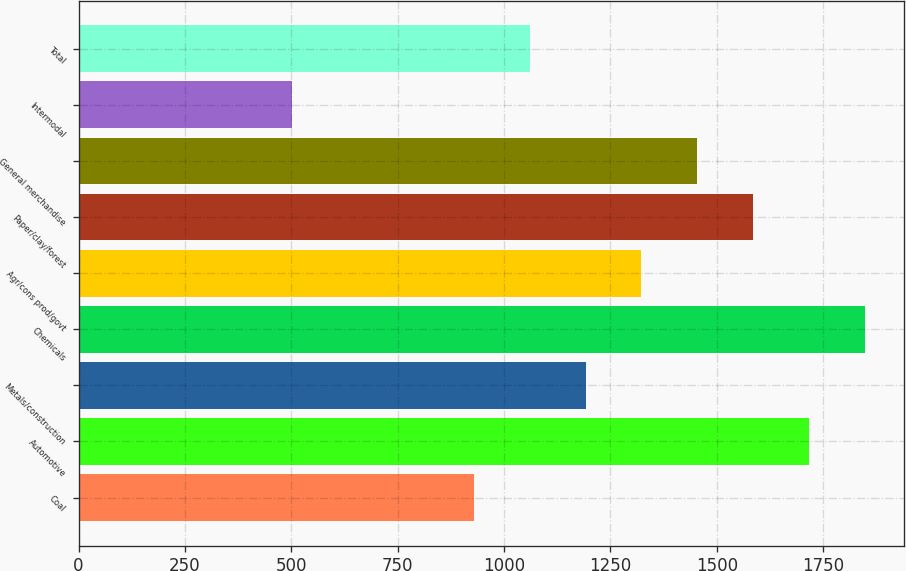Convert chart. <chart><loc_0><loc_0><loc_500><loc_500><bar_chart><fcel>Coal<fcel>Automotive<fcel>Metals/construction<fcel>Chemicals<fcel>Agr/cons prod/govt<fcel>Paper/clay/forest<fcel>General merchandise<fcel>Intermodal<fcel>Total<nl><fcel>929<fcel>1716.8<fcel>1191.6<fcel>1848.1<fcel>1322.9<fcel>1585.5<fcel>1454.2<fcel>502<fcel>1060.3<nl></chart> 